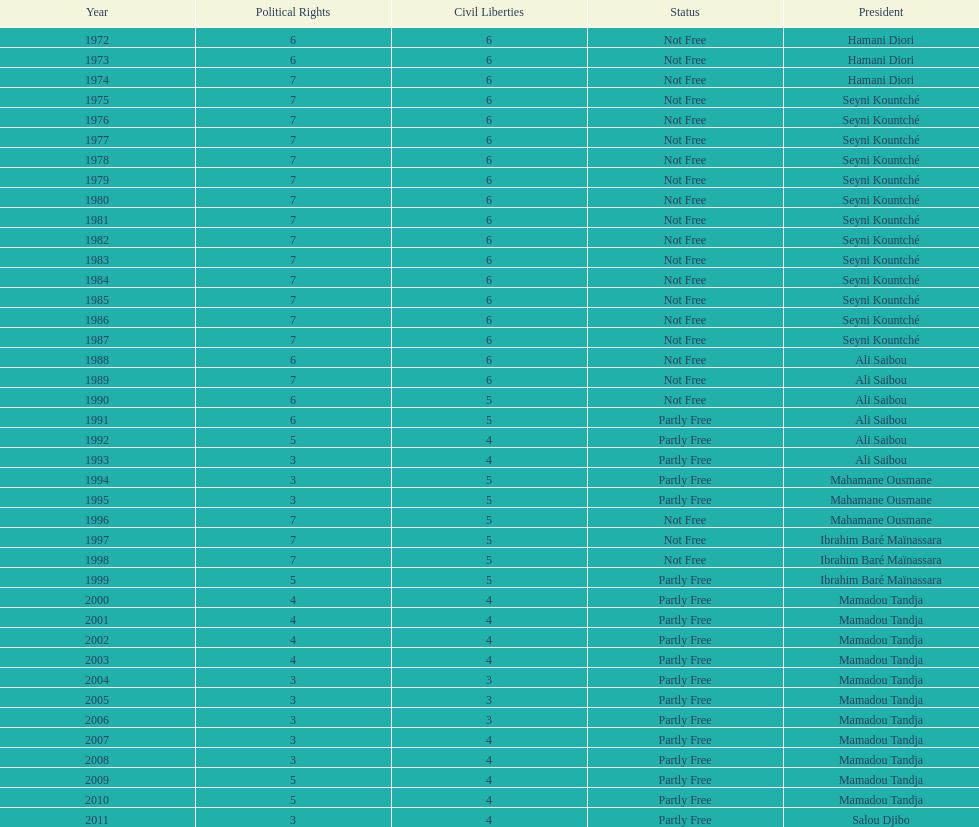How many years was ali saibou president? 6. 